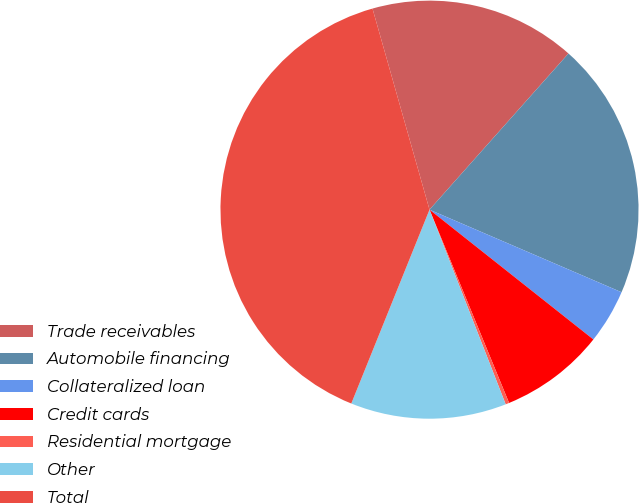<chart> <loc_0><loc_0><loc_500><loc_500><pie_chart><fcel>Trade receivables<fcel>Automobile financing<fcel>Collateralized loan<fcel>Credit cards<fcel>Residential mortgage<fcel>Other<fcel>Total<nl><fcel>15.97%<fcel>19.89%<fcel>4.2%<fcel>8.12%<fcel>0.28%<fcel>12.04%<fcel>39.5%<nl></chart> 